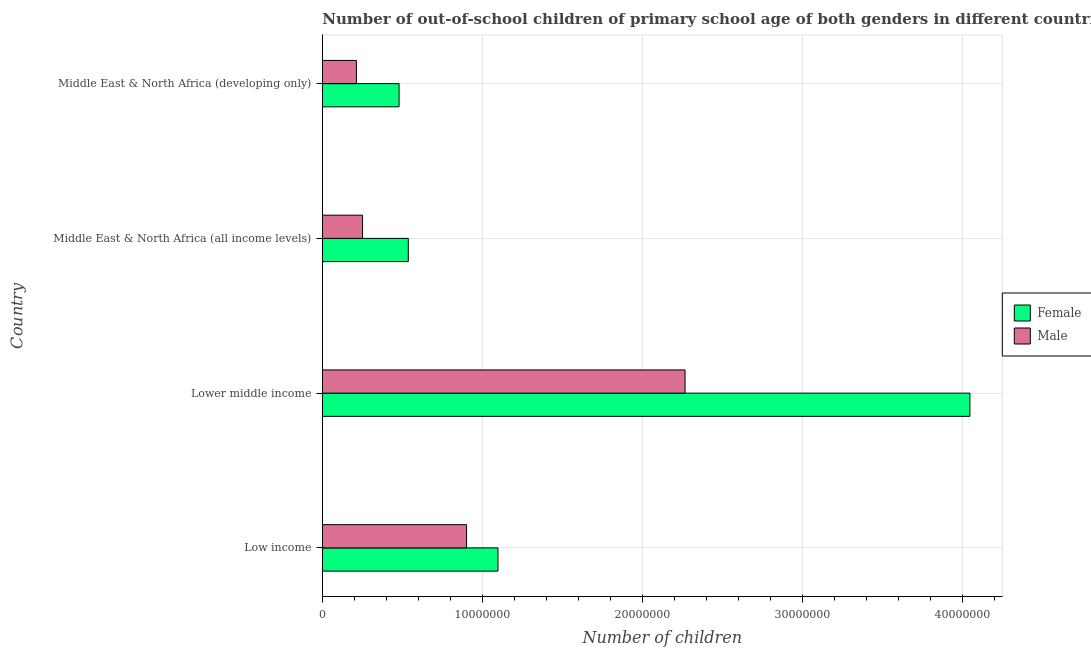How many groups of bars are there?
Keep it short and to the point. 4. Are the number of bars per tick equal to the number of legend labels?
Your answer should be compact. Yes. Are the number of bars on each tick of the Y-axis equal?
Make the answer very short. Yes. How many bars are there on the 3rd tick from the top?
Make the answer very short. 2. How many bars are there on the 2nd tick from the bottom?
Offer a very short reply. 2. What is the label of the 3rd group of bars from the top?
Your answer should be compact. Lower middle income. What is the number of female out-of-school students in Low income?
Offer a very short reply. 1.10e+07. Across all countries, what is the maximum number of female out-of-school students?
Provide a succinct answer. 4.05e+07. Across all countries, what is the minimum number of male out-of-school students?
Ensure brevity in your answer.  2.13e+06. In which country was the number of female out-of-school students maximum?
Give a very brief answer. Lower middle income. In which country was the number of female out-of-school students minimum?
Offer a terse response. Middle East & North Africa (developing only). What is the total number of female out-of-school students in the graph?
Provide a short and direct response. 6.16e+07. What is the difference between the number of male out-of-school students in Lower middle income and that in Middle East & North Africa (all income levels)?
Offer a very short reply. 2.02e+07. What is the difference between the number of female out-of-school students in Lower middle income and the number of male out-of-school students in Middle East & North Africa (developing only)?
Give a very brief answer. 3.83e+07. What is the average number of male out-of-school students per country?
Provide a succinct answer. 9.08e+06. What is the difference between the number of male out-of-school students and number of female out-of-school students in Middle East & North Africa (developing only)?
Make the answer very short. -2.67e+06. What is the ratio of the number of male out-of-school students in Middle East & North Africa (all income levels) to that in Middle East & North Africa (developing only)?
Your response must be concise. 1.18. What is the difference between the highest and the second highest number of male out-of-school students?
Keep it short and to the point. 1.37e+07. What is the difference between the highest and the lowest number of male out-of-school students?
Make the answer very short. 2.05e+07. In how many countries, is the number of female out-of-school students greater than the average number of female out-of-school students taken over all countries?
Give a very brief answer. 1. What does the 2nd bar from the top in Middle East & North Africa (developing only) represents?
Keep it short and to the point. Female. What is the difference between two consecutive major ticks on the X-axis?
Provide a succinct answer. 1.00e+07. Are the values on the major ticks of X-axis written in scientific E-notation?
Keep it short and to the point. No. How many legend labels are there?
Provide a succinct answer. 2. What is the title of the graph?
Offer a very short reply. Number of out-of-school children of primary school age of both genders in different countries. Does "Resident workers" appear as one of the legend labels in the graph?
Keep it short and to the point. No. What is the label or title of the X-axis?
Make the answer very short. Number of children. What is the Number of children of Female in Low income?
Offer a very short reply. 1.10e+07. What is the Number of children of Male in Low income?
Your answer should be compact. 9.01e+06. What is the Number of children of Female in Lower middle income?
Provide a short and direct response. 4.05e+07. What is the Number of children in Male in Lower middle income?
Provide a short and direct response. 2.27e+07. What is the Number of children of Female in Middle East & North Africa (all income levels)?
Keep it short and to the point. 5.37e+06. What is the Number of children in Male in Middle East & North Africa (all income levels)?
Provide a succinct answer. 2.51e+06. What is the Number of children of Female in Middle East & North Africa (developing only)?
Provide a succinct answer. 4.80e+06. What is the Number of children of Male in Middle East & North Africa (developing only)?
Ensure brevity in your answer.  2.13e+06. Across all countries, what is the maximum Number of children of Female?
Your answer should be compact. 4.05e+07. Across all countries, what is the maximum Number of children in Male?
Provide a succinct answer. 2.27e+07. Across all countries, what is the minimum Number of children in Female?
Make the answer very short. 4.80e+06. Across all countries, what is the minimum Number of children in Male?
Your response must be concise. 2.13e+06. What is the total Number of children of Female in the graph?
Give a very brief answer. 6.16e+07. What is the total Number of children of Male in the graph?
Offer a terse response. 3.63e+07. What is the difference between the Number of children of Female in Low income and that in Lower middle income?
Provide a succinct answer. -2.95e+07. What is the difference between the Number of children in Male in Low income and that in Lower middle income?
Your answer should be compact. -1.37e+07. What is the difference between the Number of children in Female in Low income and that in Middle East & North Africa (all income levels)?
Provide a short and direct response. 5.60e+06. What is the difference between the Number of children in Male in Low income and that in Middle East & North Africa (all income levels)?
Make the answer very short. 6.50e+06. What is the difference between the Number of children of Female in Low income and that in Middle East & North Africa (developing only)?
Your answer should be very brief. 6.18e+06. What is the difference between the Number of children of Male in Low income and that in Middle East & North Africa (developing only)?
Your answer should be compact. 6.88e+06. What is the difference between the Number of children of Female in Lower middle income and that in Middle East & North Africa (all income levels)?
Provide a short and direct response. 3.51e+07. What is the difference between the Number of children in Male in Lower middle income and that in Middle East & North Africa (all income levels)?
Your answer should be very brief. 2.02e+07. What is the difference between the Number of children in Female in Lower middle income and that in Middle East & North Africa (developing only)?
Your answer should be very brief. 3.57e+07. What is the difference between the Number of children in Male in Lower middle income and that in Middle East & North Africa (developing only)?
Your answer should be compact. 2.05e+07. What is the difference between the Number of children in Female in Middle East & North Africa (all income levels) and that in Middle East & North Africa (developing only)?
Provide a short and direct response. 5.76e+05. What is the difference between the Number of children of Male in Middle East & North Africa (all income levels) and that in Middle East & North Africa (developing only)?
Your answer should be very brief. 3.85e+05. What is the difference between the Number of children in Female in Low income and the Number of children in Male in Lower middle income?
Provide a short and direct response. -1.17e+07. What is the difference between the Number of children of Female in Low income and the Number of children of Male in Middle East & North Africa (all income levels)?
Offer a terse response. 8.46e+06. What is the difference between the Number of children in Female in Low income and the Number of children in Male in Middle East & North Africa (developing only)?
Make the answer very short. 8.85e+06. What is the difference between the Number of children in Female in Lower middle income and the Number of children in Male in Middle East & North Africa (all income levels)?
Your answer should be very brief. 3.80e+07. What is the difference between the Number of children in Female in Lower middle income and the Number of children in Male in Middle East & North Africa (developing only)?
Make the answer very short. 3.83e+07. What is the difference between the Number of children in Female in Middle East & North Africa (all income levels) and the Number of children in Male in Middle East & North Africa (developing only)?
Give a very brief answer. 3.24e+06. What is the average Number of children of Female per country?
Your answer should be compact. 1.54e+07. What is the average Number of children of Male per country?
Provide a succinct answer. 9.08e+06. What is the difference between the Number of children in Female and Number of children in Male in Low income?
Keep it short and to the point. 1.96e+06. What is the difference between the Number of children in Female and Number of children in Male in Lower middle income?
Make the answer very short. 1.78e+07. What is the difference between the Number of children in Female and Number of children in Male in Middle East & North Africa (all income levels)?
Make the answer very short. 2.86e+06. What is the difference between the Number of children in Female and Number of children in Male in Middle East & North Africa (developing only)?
Make the answer very short. 2.67e+06. What is the ratio of the Number of children in Female in Low income to that in Lower middle income?
Give a very brief answer. 0.27. What is the ratio of the Number of children in Male in Low income to that in Lower middle income?
Provide a succinct answer. 0.4. What is the ratio of the Number of children in Female in Low income to that in Middle East & North Africa (all income levels)?
Keep it short and to the point. 2.04. What is the ratio of the Number of children of Male in Low income to that in Middle East & North Africa (all income levels)?
Offer a very short reply. 3.59. What is the ratio of the Number of children of Female in Low income to that in Middle East & North Africa (developing only)?
Your answer should be very brief. 2.29. What is the ratio of the Number of children of Male in Low income to that in Middle East & North Africa (developing only)?
Offer a very short reply. 4.23. What is the ratio of the Number of children in Female in Lower middle income to that in Middle East & North Africa (all income levels)?
Offer a terse response. 7.53. What is the ratio of the Number of children in Male in Lower middle income to that in Middle East & North Africa (all income levels)?
Give a very brief answer. 9.02. What is the ratio of the Number of children in Female in Lower middle income to that in Middle East & North Africa (developing only)?
Provide a short and direct response. 8.44. What is the ratio of the Number of children of Male in Lower middle income to that in Middle East & North Africa (developing only)?
Provide a short and direct response. 10.65. What is the ratio of the Number of children in Female in Middle East & North Africa (all income levels) to that in Middle East & North Africa (developing only)?
Give a very brief answer. 1.12. What is the ratio of the Number of children in Male in Middle East & North Africa (all income levels) to that in Middle East & North Africa (developing only)?
Make the answer very short. 1.18. What is the difference between the highest and the second highest Number of children of Female?
Your answer should be very brief. 2.95e+07. What is the difference between the highest and the second highest Number of children of Male?
Give a very brief answer. 1.37e+07. What is the difference between the highest and the lowest Number of children of Female?
Offer a very short reply. 3.57e+07. What is the difference between the highest and the lowest Number of children of Male?
Offer a very short reply. 2.05e+07. 